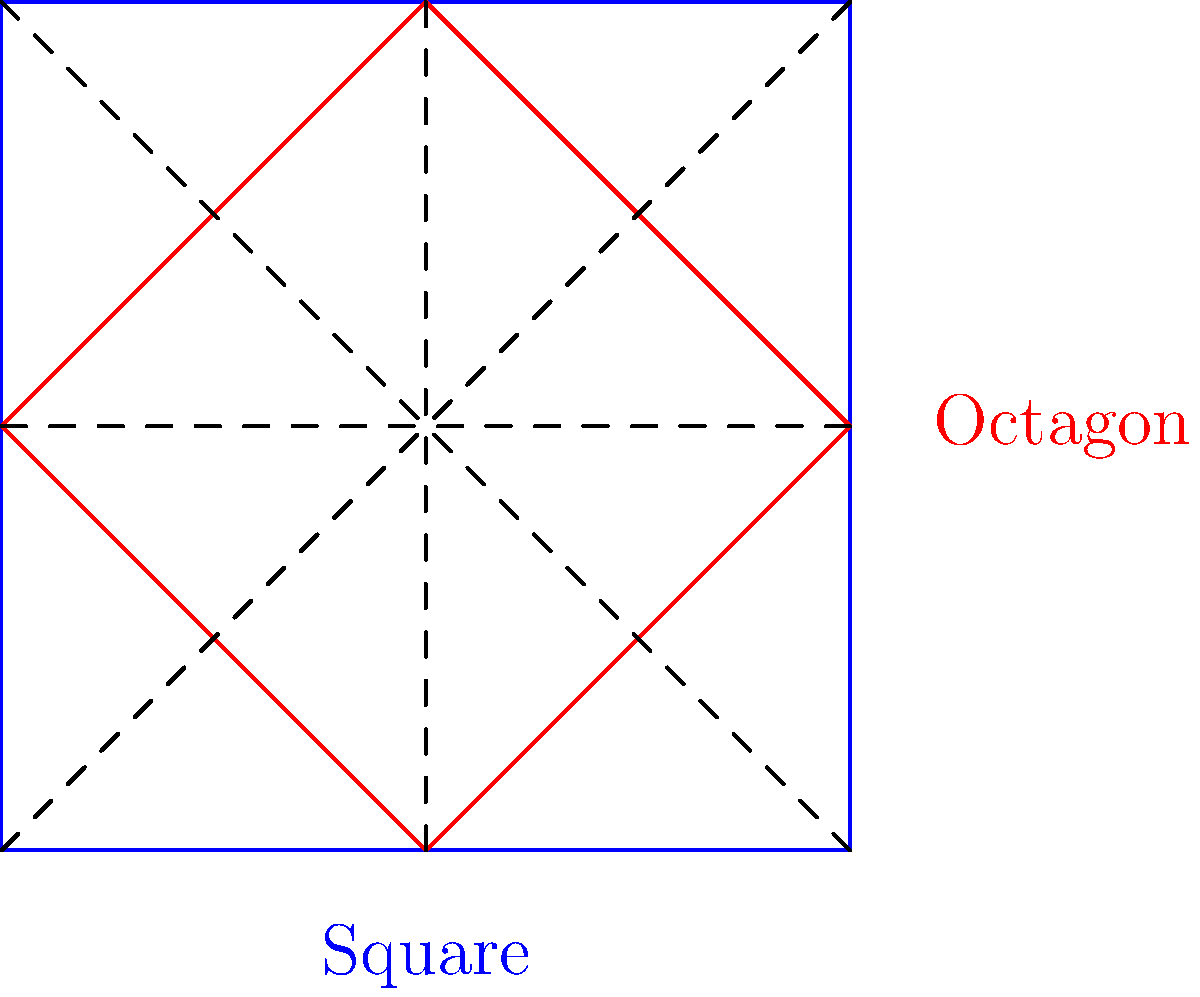As a retired construction worker planning a community gathering space, you're considering two shapes: a square and an octagon, both with the same perimeter. Which shape would provide more usable area for community activities? Let's approach this step-by-step:

1) First, recall that for a given perimeter, the shape with the largest area is a circle.

2) Among polygons, the more sides a regular polygon has, the closer its area gets to that of a circle with the same perimeter.

3) In this case, we're comparing a square (4 sides) to an octagon (8 sides).

4) Let's consider the mathematical relationship:
   For a square with side length $s$:
   Perimeter = $4s$
   Area = $s^2$

   For a regular octagon with side length $a$:
   Perimeter = $8a$
   Area = $2a^2(1+\sqrt{2})$

5) If we set the perimeters equal:
   $4s = 8a$
   $s = 2a$

6) Now, let's compare the areas:
   Square area: $s^2 = (2a)^2 = 4a^2$
   Octagon area: $2a^2(1+\sqrt{2}) \approx 4.83a^2$

7) We can see that $4.83a^2 > 4a^2$, meaning the octagon has a larger area for the same perimeter.

In the context of construction and community spaces, the octagon would provide more usable area while maintaining the same boundary length as a square. This extra space could be valuable for community gatherings and activities.
Answer: Octagon 